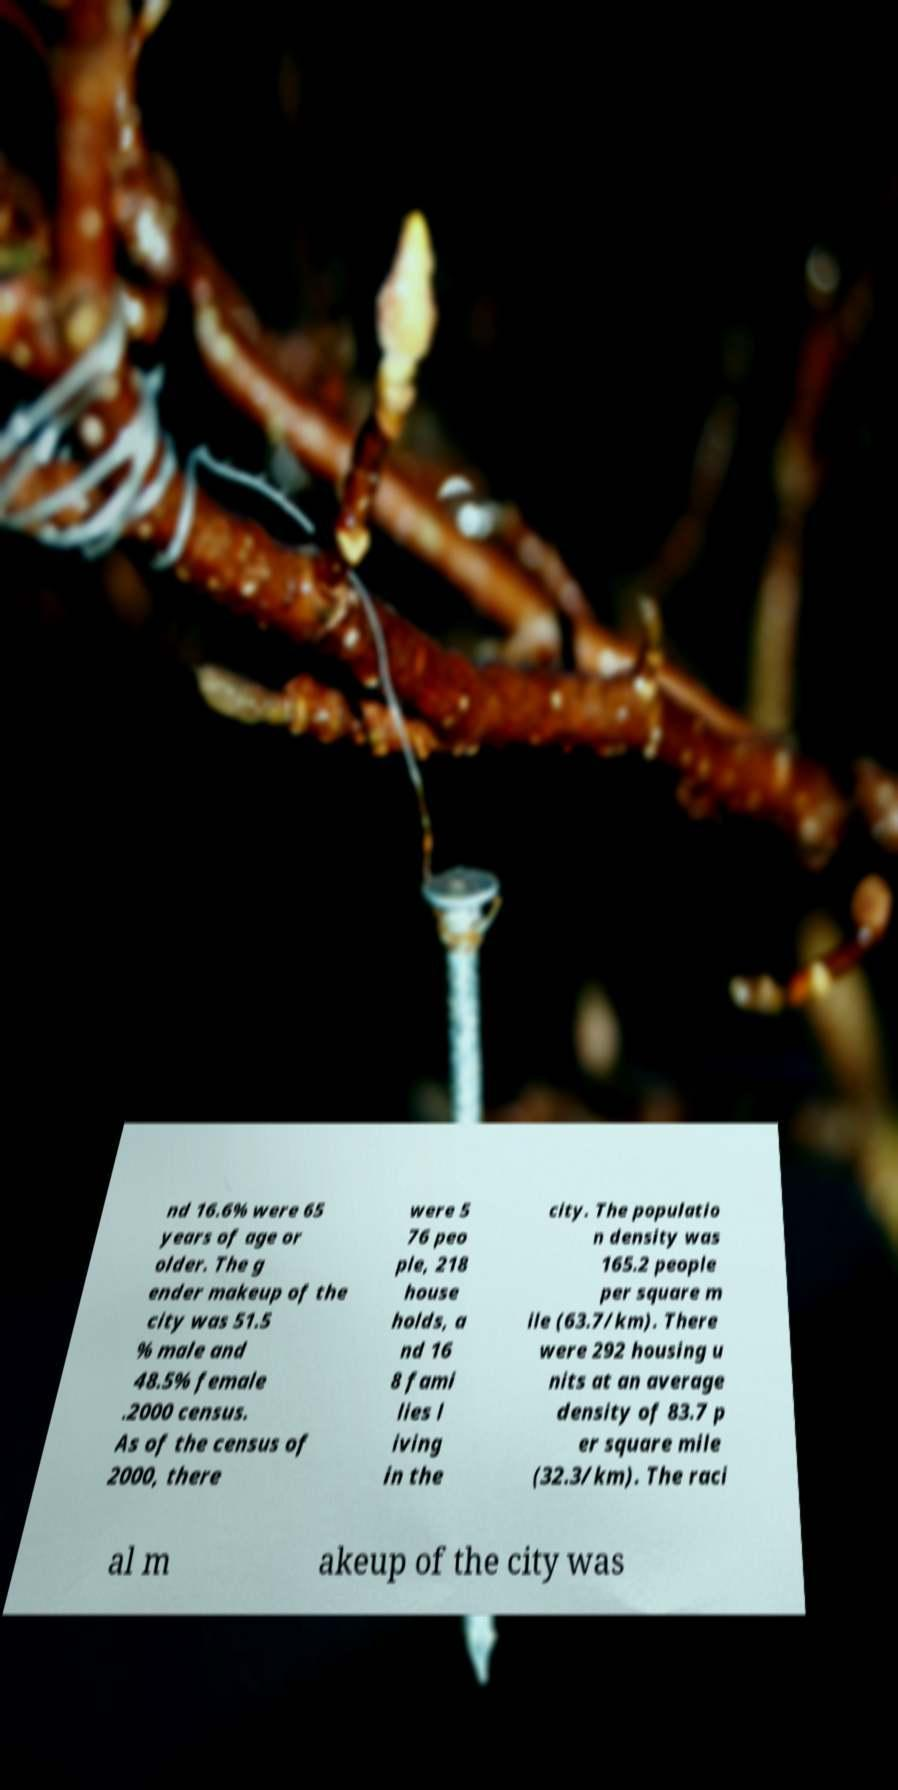Could you extract and type out the text from this image? nd 16.6% were 65 years of age or older. The g ender makeup of the city was 51.5 % male and 48.5% female .2000 census. As of the census of 2000, there were 5 76 peo ple, 218 house holds, a nd 16 8 fami lies l iving in the city. The populatio n density was 165.2 people per square m ile (63.7/km). There were 292 housing u nits at an average density of 83.7 p er square mile (32.3/km). The raci al m akeup of the city was 